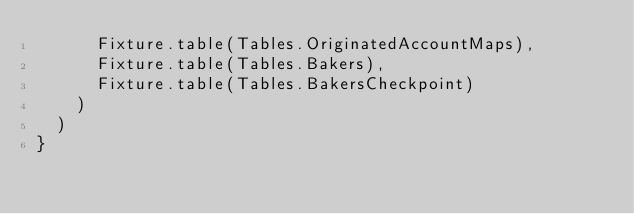Convert code to text. <code><loc_0><loc_0><loc_500><loc_500><_Scala_>      Fixture.table(Tables.OriginatedAccountMaps),
      Fixture.table(Tables.Bakers),
      Fixture.table(Tables.BakersCheckpoint)
    )
  )
}
</code> 